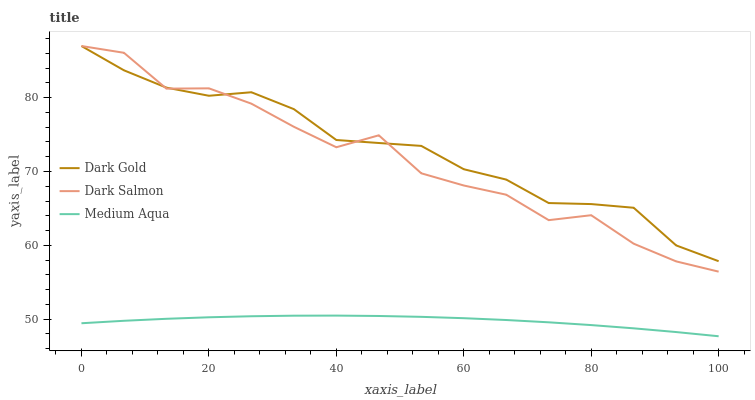Does Medium Aqua have the minimum area under the curve?
Answer yes or no. Yes. Does Dark Gold have the maximum area under the curve?
Answer yes or no. Yes. Does Dark Salmon have the minimum area under the curve?
Answer yes or no. No. Does Dark Salmon have the maximum area under the curve?
Answer yes or no. No. Is Medium Aqua the smoothest?
Answer yes or no. Yes. Is Dark Salmon the roughest?
Answer yes or no. Yes. Is Dark Gold the smoothest?
Answer yes or no. No. Is Dark Gold the roughest?
Answer yes or no. No. Does Medium Aqua have the lowest value?
Answer yes or no. Yes. Does Dark Salmon have the lowest value?
Answer yes or no. No. Does Dark Gold have the highest value?
Answer yes or no. Yes. Is Medium Aqua less than Dark Salmon?
Answer yes or no. Yes. Is Dark Salmon greater than Medium Aqua?
Answer yes or no. Yes. Does Dark Salmon intersect Dark Gold?
Answer yes or no. Yes. Is Dark Salmon less than Dark Gold?
Answer yes or no. No. Is Dark Salmon greater than Dark Gold?
Answer yes or no. No. Does Medium Aqua intersect Dark Salmon?
Answer yes or no. No. 